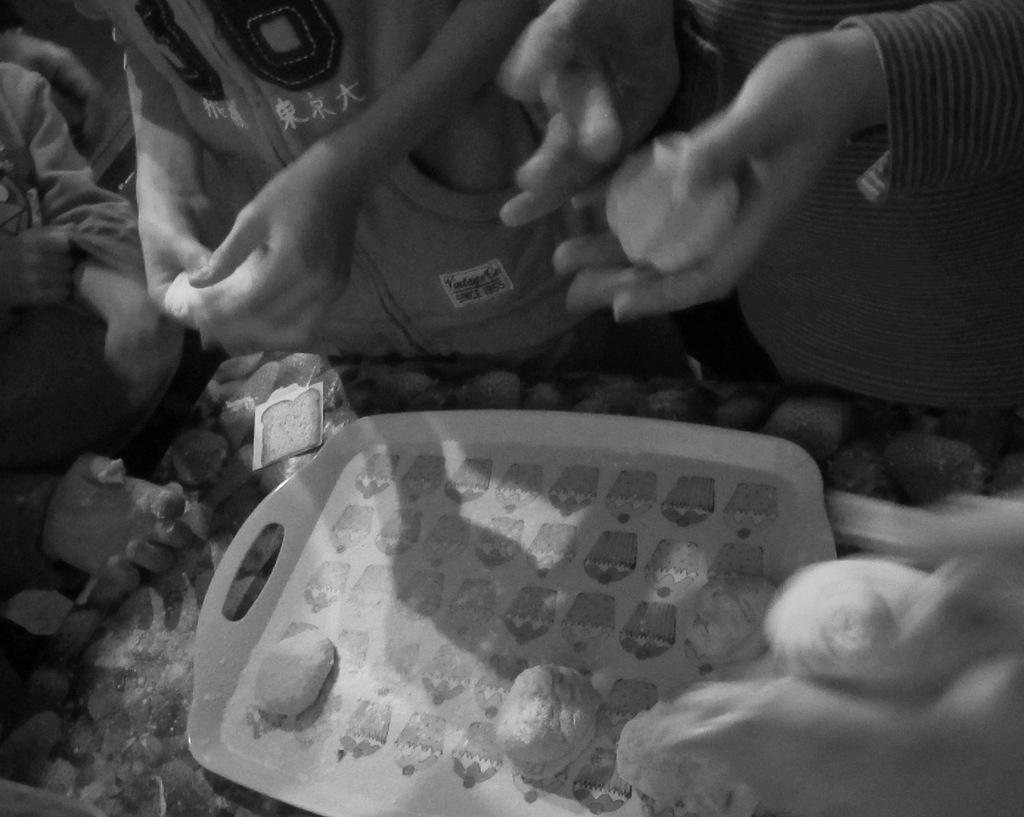What is present on the tray in the image? There are food items on a tray in the image. Where is the tray located? The tray is placed on a table in the image. Are there any people in the image? Yes, there are people around the table in the image. What is the color scheme of the image? The image is black and white. What type of shoes can be seen on the people in the image? There are no shoes visible in the image, as it is focused on the food items on the tray and the people around the table. 